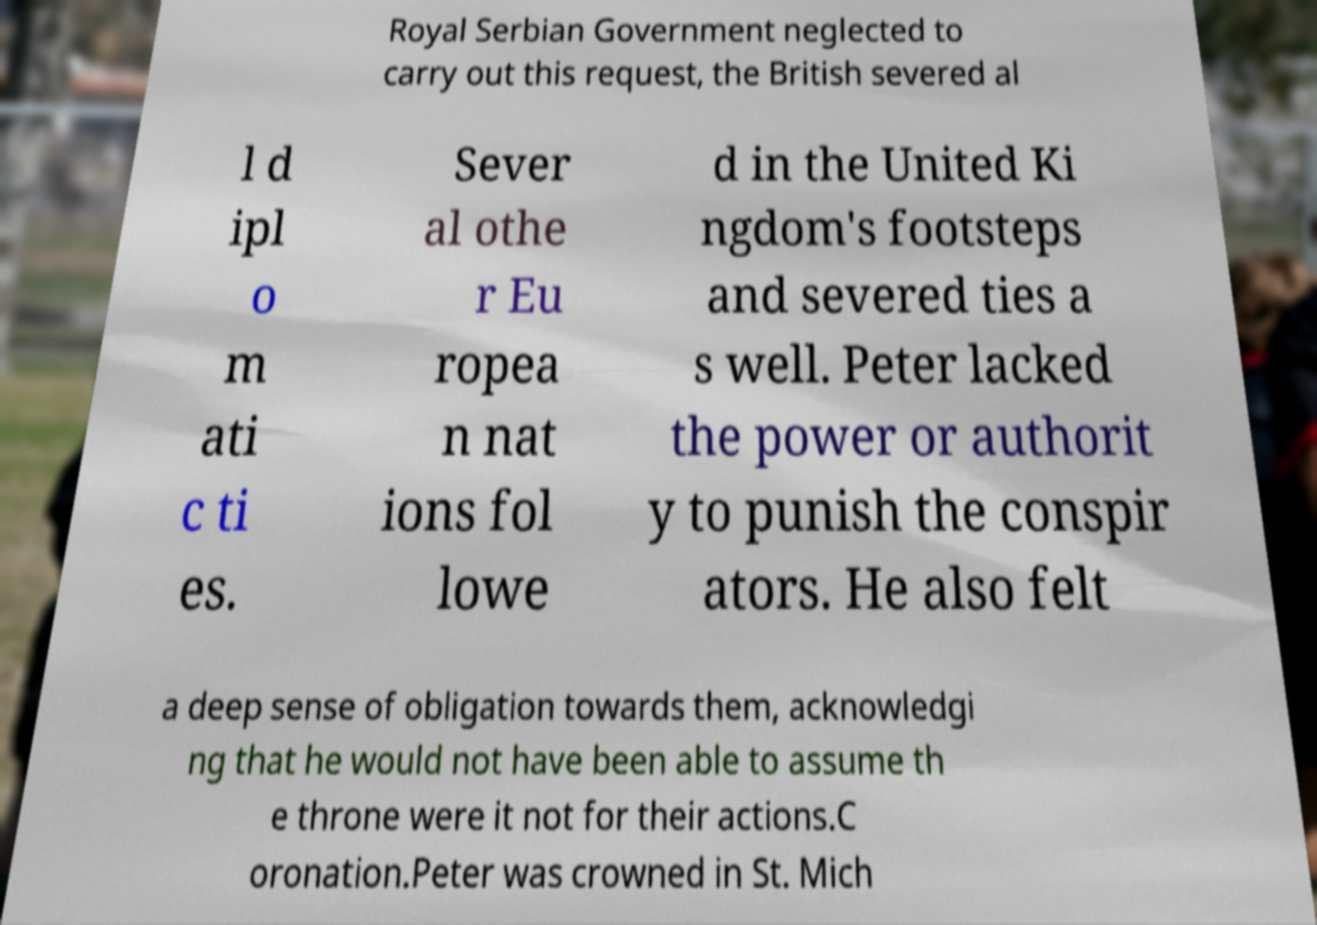Please read and relay the text visible in this image. What does it say? Royal Serbian Government neglected to carry out this request, the British severed al l d ipl o m ati c ti es. Sever al othe r Eu ropea n nat ions fol lowe d in the United Ki ngdom's footsteps and severed ties a s well. Peter lacked the power or authorit y to punish the conspir ators. He also felt a deep sense of obligation towards them, acknowledgi ng that he would not have been able to assume th e throne were it not for their actions.C oronation.Peter was crowned in St. Mich 